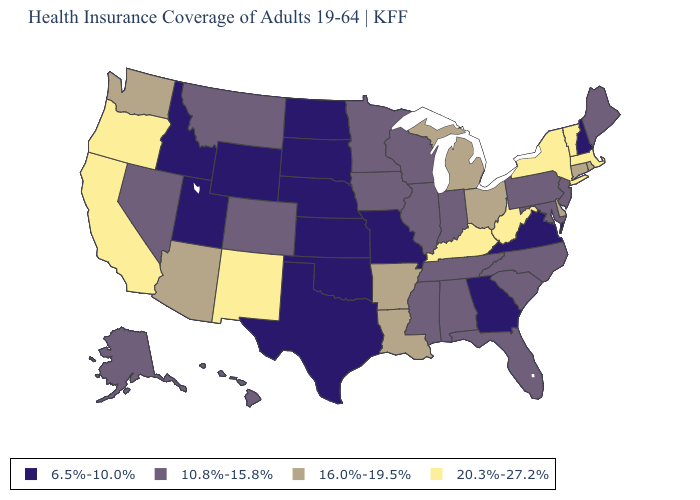What is the highest value in the MidWest ?
Answer briefly. 16.0%-19.5%. Does Oregon have the highest value in the USA?
Short answer required. Yes. Is the legend a continuous bar?
Keep it brief. No. How many symbols are there in the legend?
Quick response, please. 4. Among the states that border Wyoming , does Utah have the highest value?
Answer briefly. No. What is the value of Delaware?
Concise answer only. 16.0%-19.5%. Does the map have missing data?
Be succinct. No. Name the states that have a value in the range 16.0%-19.5%?
Keep it brief. Arizona, Arkansas, Connecticut, Delaware, Louisiana, Michigan, Ohio, Rhode Island, Washington. What is the value of Montana?
Short answer required. 10.8%-15.8%. Among the states that border Rhode Island , which have the lowest value?
Answer briefly. Connecticut. Name the states that have a value in the range 10.8%-15.8%?
Write a very short answer. Alabama, Alaska, Colorado, Florida, Hawaii, Illinois, Indiana, Iowa, Maine, Maryland, Minnesota, Mississippi, Montana, Nevada, New Jersey, North Carolina, Pennsylvania, South Carolina, Tennessee, Wisconsin. Name the states that have a value in the range 6.5%-10.0%?
Keep it brief. Georgia, Idaho, Kansas, Missouri, Nebraska, New Hampshire, North Dakota, Oklahoma, South Dakota, Texas, Utah, Virginia, Wyoming. Name the states that have a value in the range 16.0%-19.5%?
Be succinct. Arizona, Arkansas, Connecticut, Delaware, Louisiana, Michigan, Ohio, Rhode Island, Washington. Does Kansas have the lowest value in the MidWest?
Short answer required. Yes. What is the highest value in the Northeast ?
Answer briefly. 20.3%-27.2%. 